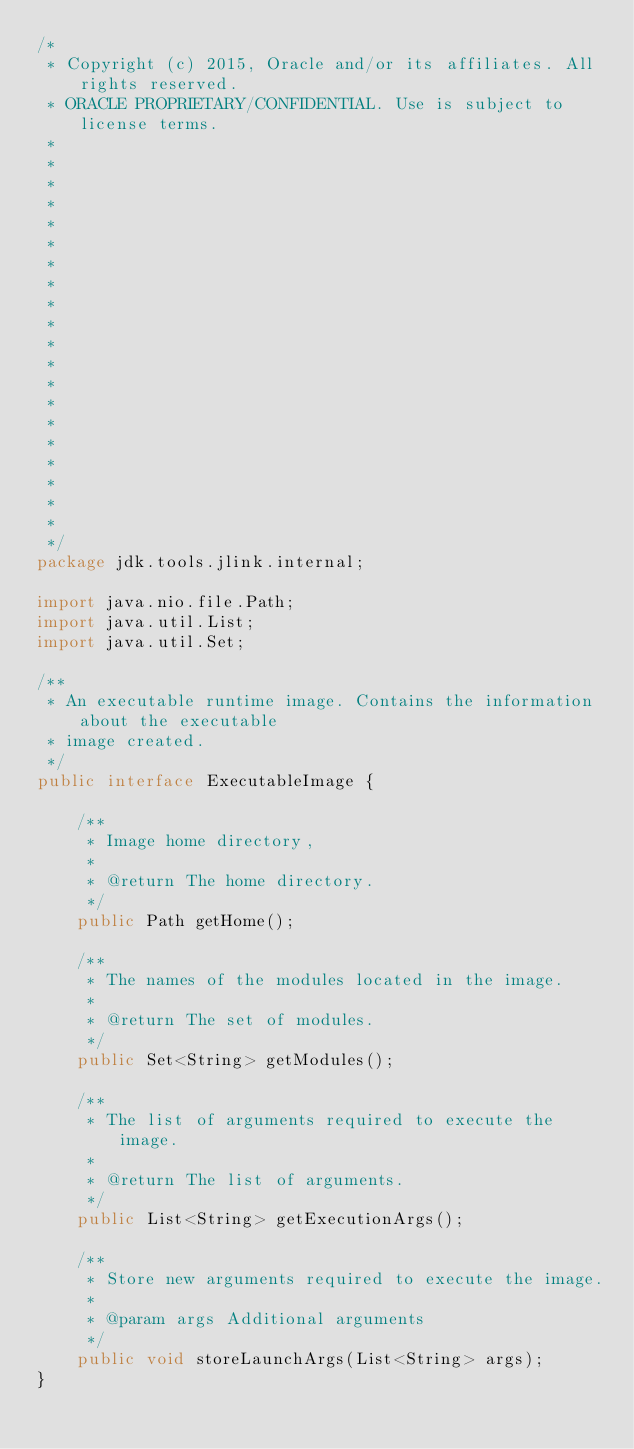Convert code to text. <code><loc_0><loc_0><loc_500><loc_500><_Java_>/*
 * Copyright (c) 2015, Oracle and/or its affiliates. All rights reserved.
 * ORACLE PROPRIETARY/CONFIDENTIAL. Use is subject to license terms.
 *
 *
 *
 *
 *
 *
 *
 *
 *
 *
 *
 *
 *
 *
 *
 *
 *
 *
 *
 *
 */
package jdk.tools.jlink.internal;

import java.nio.file.Path;
import java.util.List;
import java.util.Set;

/**
 * An executable runtime image. Contains the information about the executable
 * image created.
 */
public interface ExecutableImage {

    /**
     * Image home directory,
     *
     * @return The home directory.
     */
    public Path getHome();

    /**
     * The names of the modules located in the image.
     *
     * @return The set of modules.
     */
    public Set<String> getModules();

    /**
     * The list of arguments required to execute the image.
     *
     * @return The list of arguments.
     */
    public List<String> getExecutionArgs();

    /**
     * Store new arguments required to execute the image.
     *
     * @param args Additional arguments
     */
    public void storeLaunchArgs(List<String> args);
}
</code> 